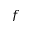Convert formula to latex. <formula><loc_0><loc_0><loc_500><loc_500>f</formula> 